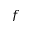Convert formula to latex. <formula><loc_0><loc_0><loc_500><loc_500>f</formula> 